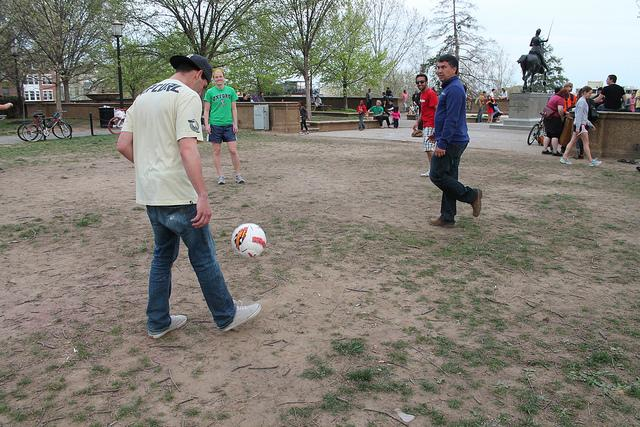What sport other that the ball's proper sport does the ball look closest to belonging to? Please explain your reasoning. volleyball. They do look similar. 